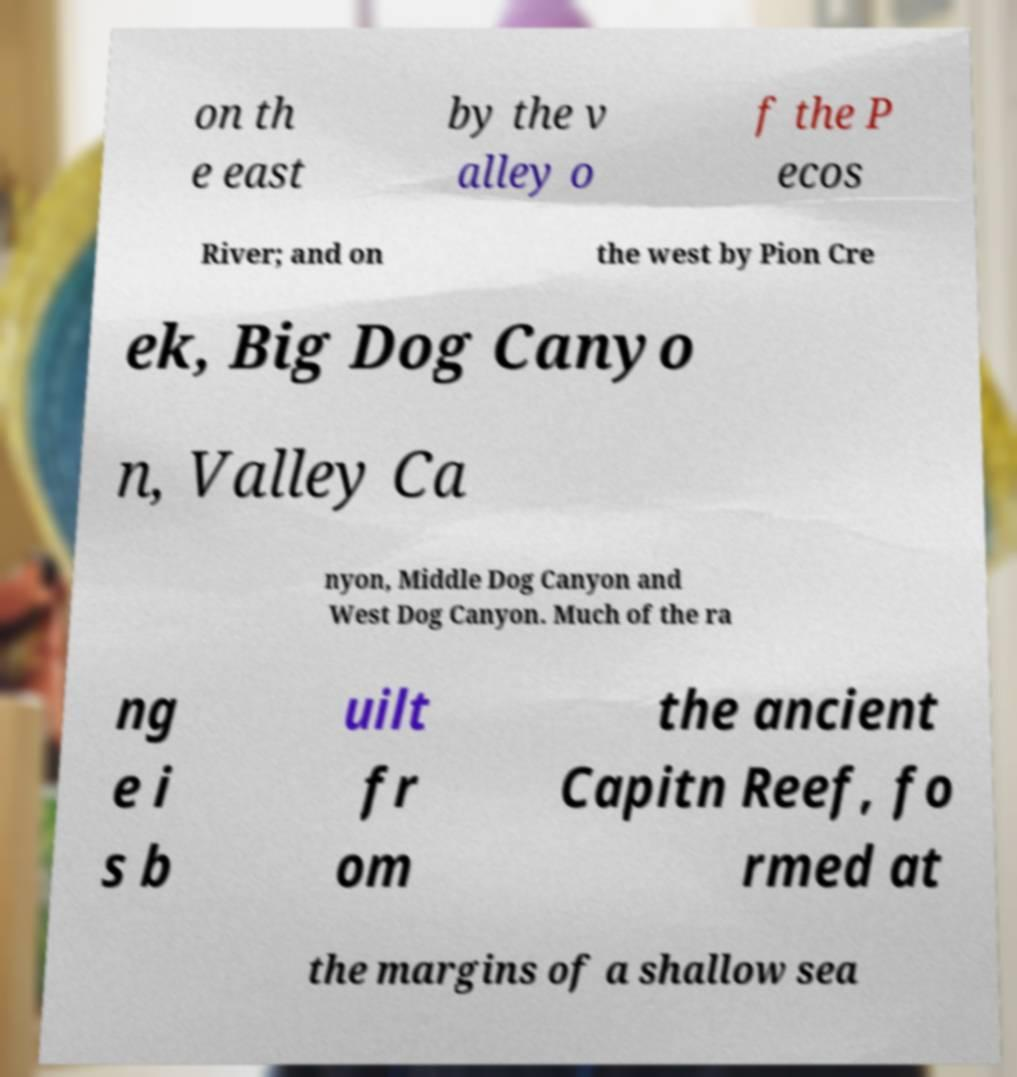I need the written content from this picture converted into text. Can you do that? on th e east by the v alley o f the P ecos River; and on the west by Pion Cre ek, Big Dog Canyo n, Valley Ca nyon, Middle Dog Canyon and West Dog Canyon. Much of the ra ng e i s b uilt fr om the ancient Capitn Reef, fo rmed at the margins of a shallow sea 